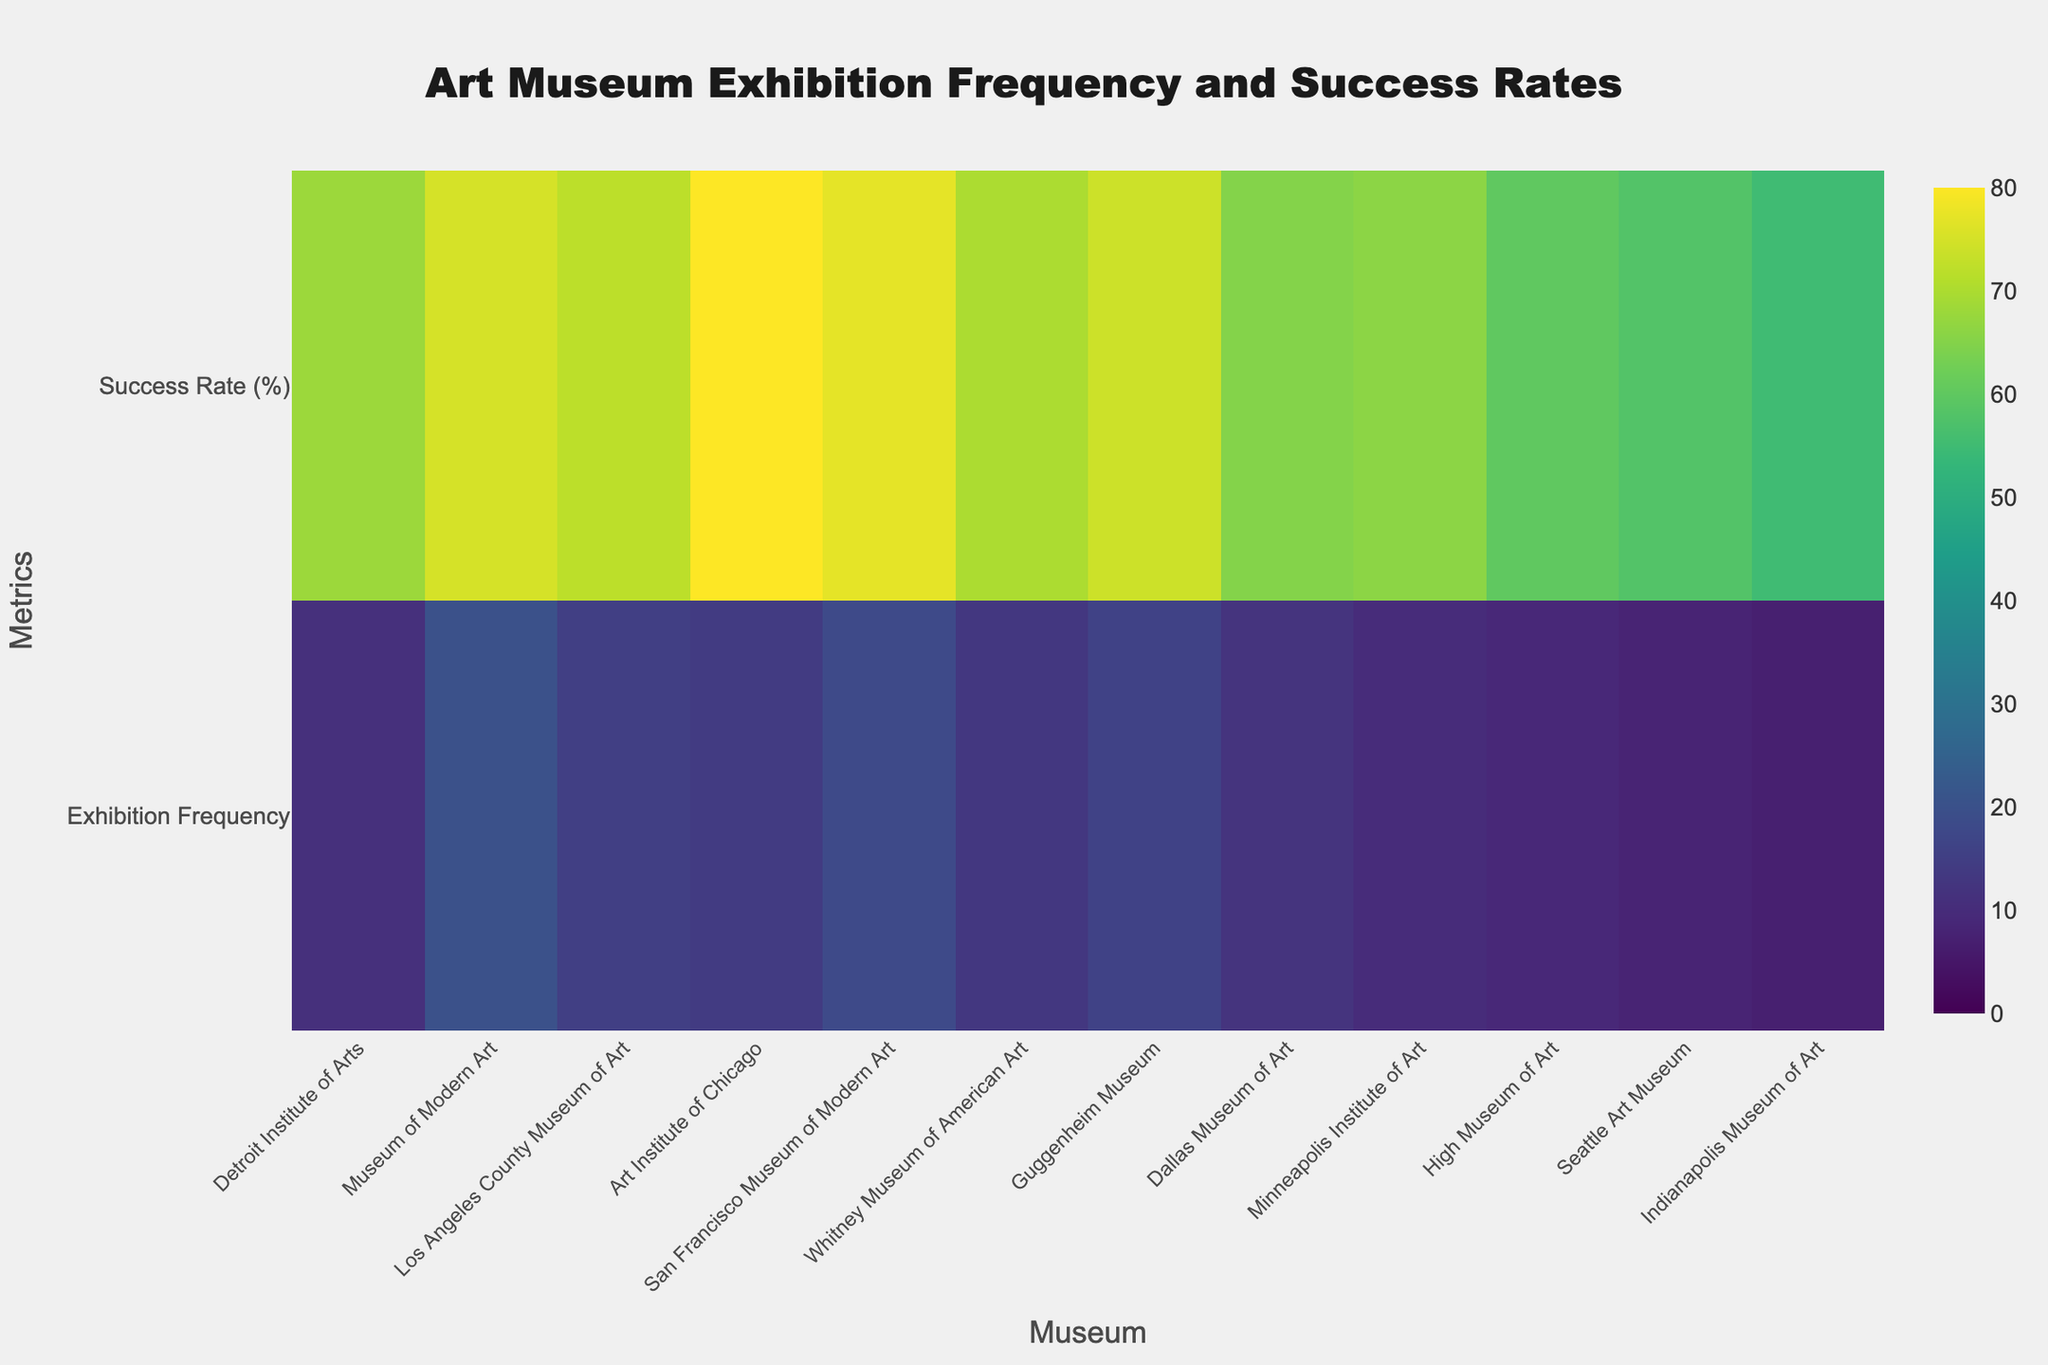What's the title of the figure? The title is usually displayed at the top of the figure. By examining the image, the title reads "Art Museum Exhibition Frequency and Success Rates."
Answer: Art Museum Exhibition Frequency and Success Rates How many art museums are displayed in the heatmap? Each museum is represented by a labeled tick along the x-axis. By counting these labels, we can determine there are twelve museums.
Answer: Twelve Which museum has the highest exhibition frequency per year? The exhibition frequency is displayed for each museum on the heatmap. The Detroit Institute of Arts is the one with the maximum value among other museums.
Answer: Museum of Modern Art (20) What is the success rate of featured artists at the Seattle Art Museum? The heatmap shows values for different metrics at each museum. The value corresponding to the "Success Rate (%)" metric for Seattle Art Museum can be found.
Answer: 58% Which museum has the lowest success rate of featured artists? By comparing the values in the heatmap under the "Success Rate (%)" metric, the Indianapolis Museum of Art shows the lowest success rate.
Answer: Indianapolis Museum of Art What is the average exhibition frequency per year across all museums? First, add up the exhibition frequencies for all museums: 11 + 20 + 15 + 14 + 18 + 13 + 16 + 12 + 10 + 9 + 8 + 7 = 153. Then, divide this sum by the number of museums (12). 153/12 = 12.75
Answer: 12.75 What is the combined success rate for the San Francisco Museum of Modern Art and the Whitney Museum of American Art? First, sum the success rates for both museums: 77 + 70 = 147. Then, divide this by the number of museums (2) to get the average. 147/2 = 73.5
Answer: 73.5 Which two museums have the closest exhibition frequency? By observing the values in the "Exhibition Frequency" row, the Dallas Museum of Art (13) and Whitney Museum of American Art (12) have the closest exhibition frequencies.
Answer: Dallas Museum of Art and Whitney Museum of American Art Does the Dallas Museum of Art have a higher success rate than the High Museum of Art? By comparing the values of the "Success Rate (%)" for both museums, Dallas Museum of Art (65%) has a higher rate than High Museum of Art (60%).
Answer: Yes Is there any museum with both higher exhibition frequency and higher success rate than the Art Institute of Chicago? Art Institute of Chicago has an exhibition frequency of 14 and a success rate of 80%. No other museum in the figure has both values higher.
Answer: No 